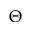Convert formula to latex. <formula><loc_0><loc_0><loc_500><loc_500>\Theta</formula> 